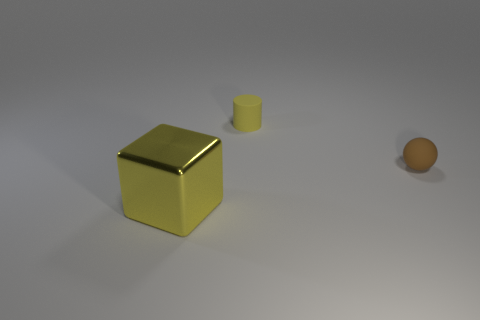What material is the small thing that is the same color as the big block?
Offer a terse response. Rubber. Is there anything else that is the same size as the metal object?
Your answer should be very brief. No. There is a small ball that is to the right of the yellow thing on the right side of the yellow cube; what is it made of?
Offer a terse response. Rubber. Are there more tiny rubber objects that are on the left side of the tiny brown object than big shiny cubes that are in front of the yellow metallic object?
Provide a succinct answer. Yes. What size is the ball?
Give a very brief answer. Small. There is a object left of the rubber cylinder; is its color the same as the cylinder?
Provide a short and direct response. Yes. Are there any other things that are the same shape as the brown object?
Offer a terse response. No. There is a yellow object on the right side of the big metallic block; is there a object that is to the right of it?
Make the answer very short. Yes. Is the number of large yellow objects that are behind the yellow cube less than the number of tiny yellow cylinders to the left of the small brown rubber ball?
Keep it short and to the point. Yes. What is the size of the yellow thing that is in front of the thing that is to the right of the yellow object that is behind the large yellow cube?
Provide a succinct answer. Large. 